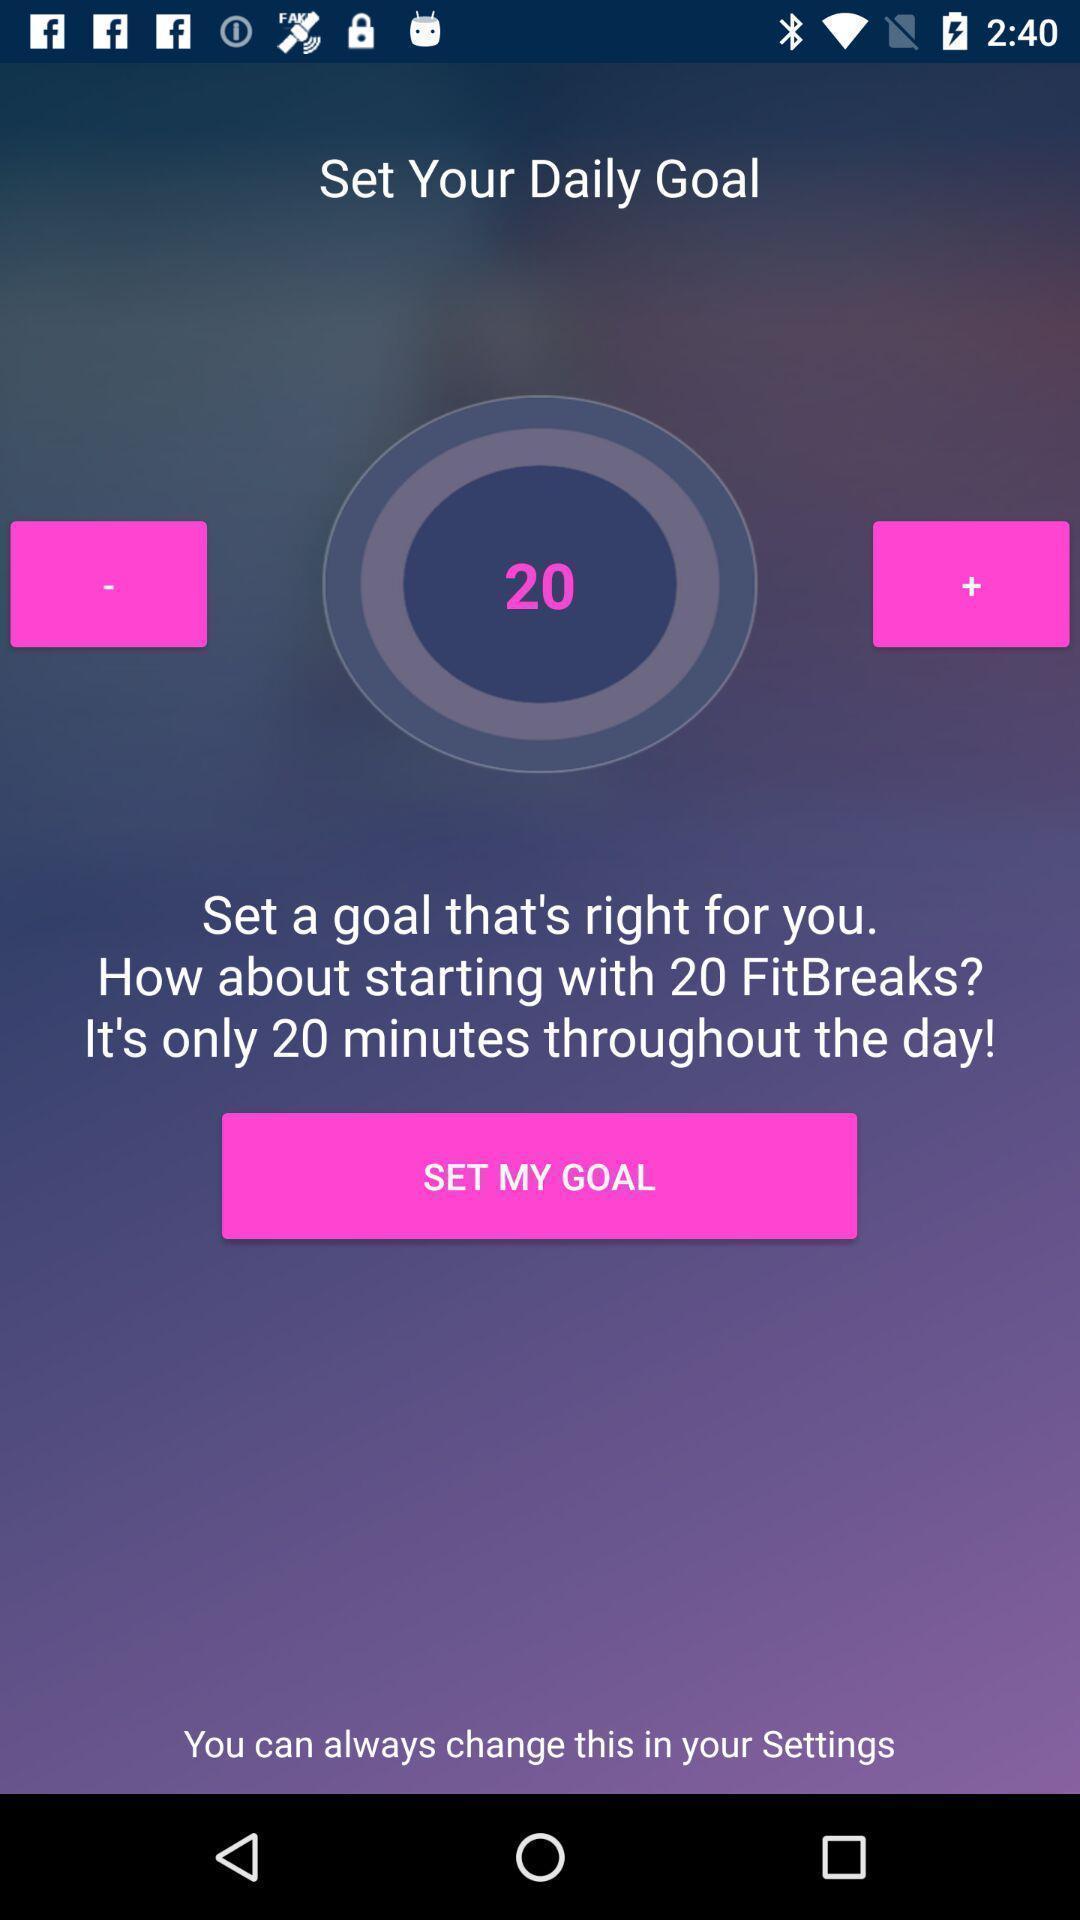Summarize the main components in this picture. Page showing timer of a fitness app. 